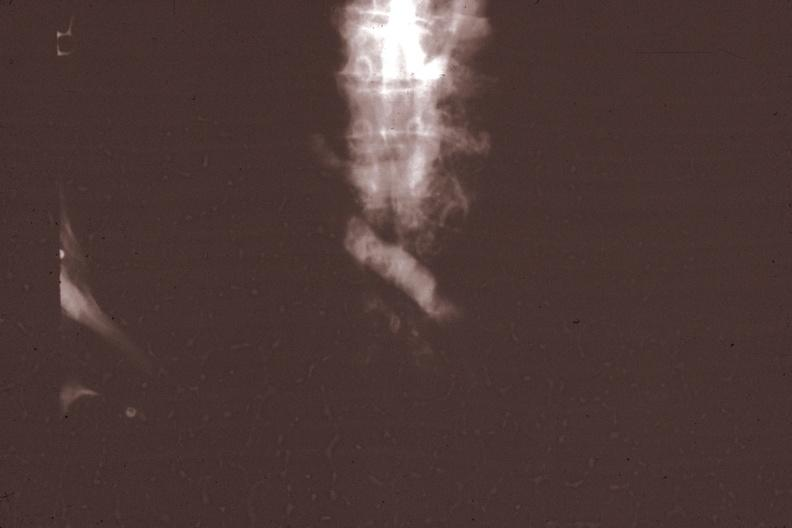what is present?
Answer the question using a single word or phrase. Hematologic 